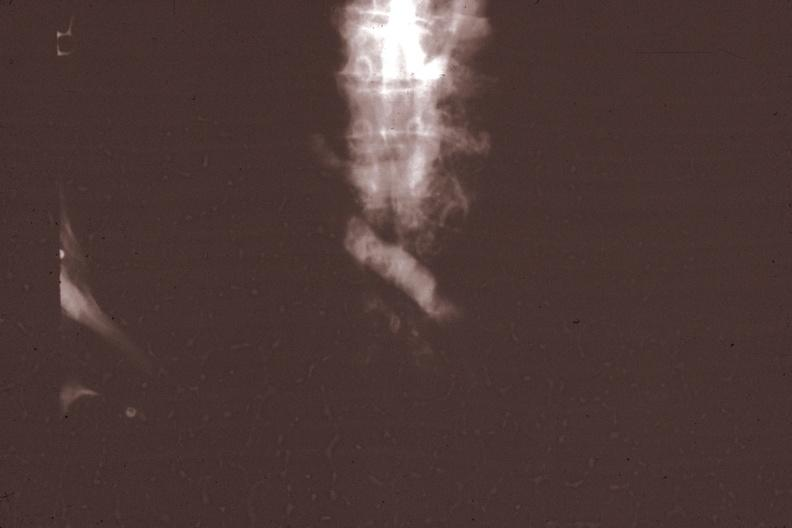what is present?
Answer the question using a single word or phrase. Hematologic 